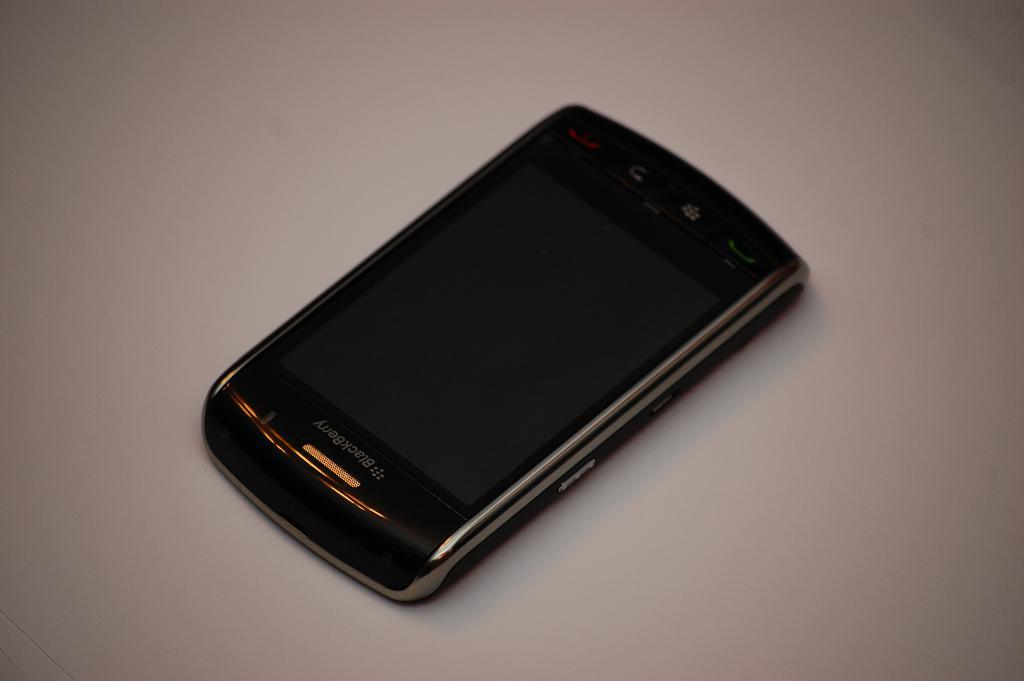<image>
Offer a succinct explanation of the picture presented. the word Blackberry is at the top of a phone 